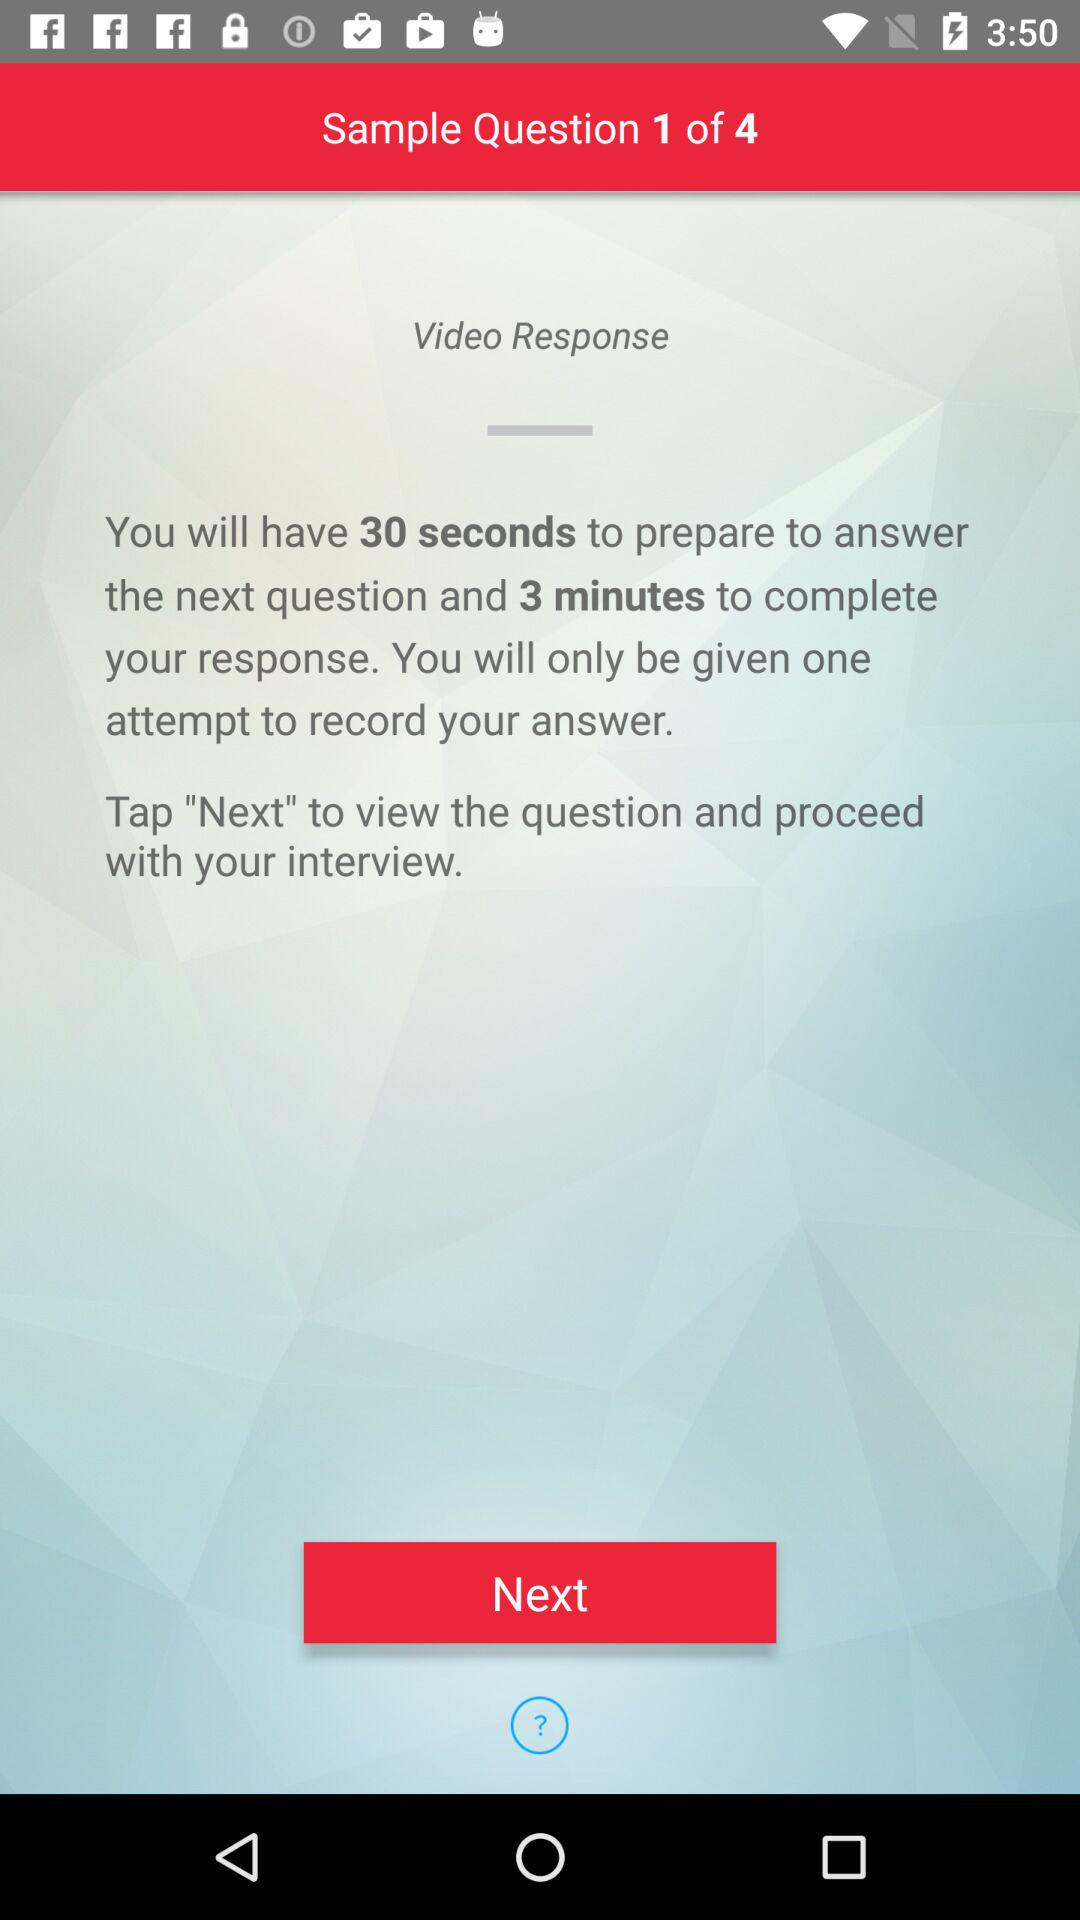Which question are we on? You are on the first question. 